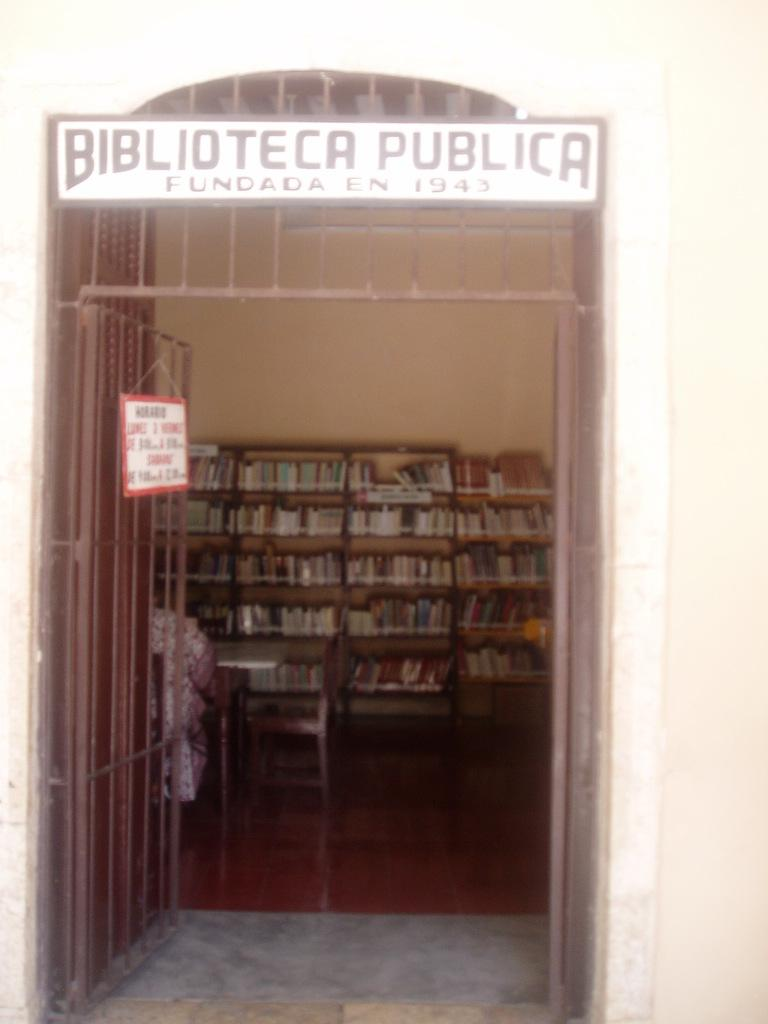<image>
Provide a brief description of the given image. An open door leading into a library with the wording Biblioteca Publica over the doorway. 